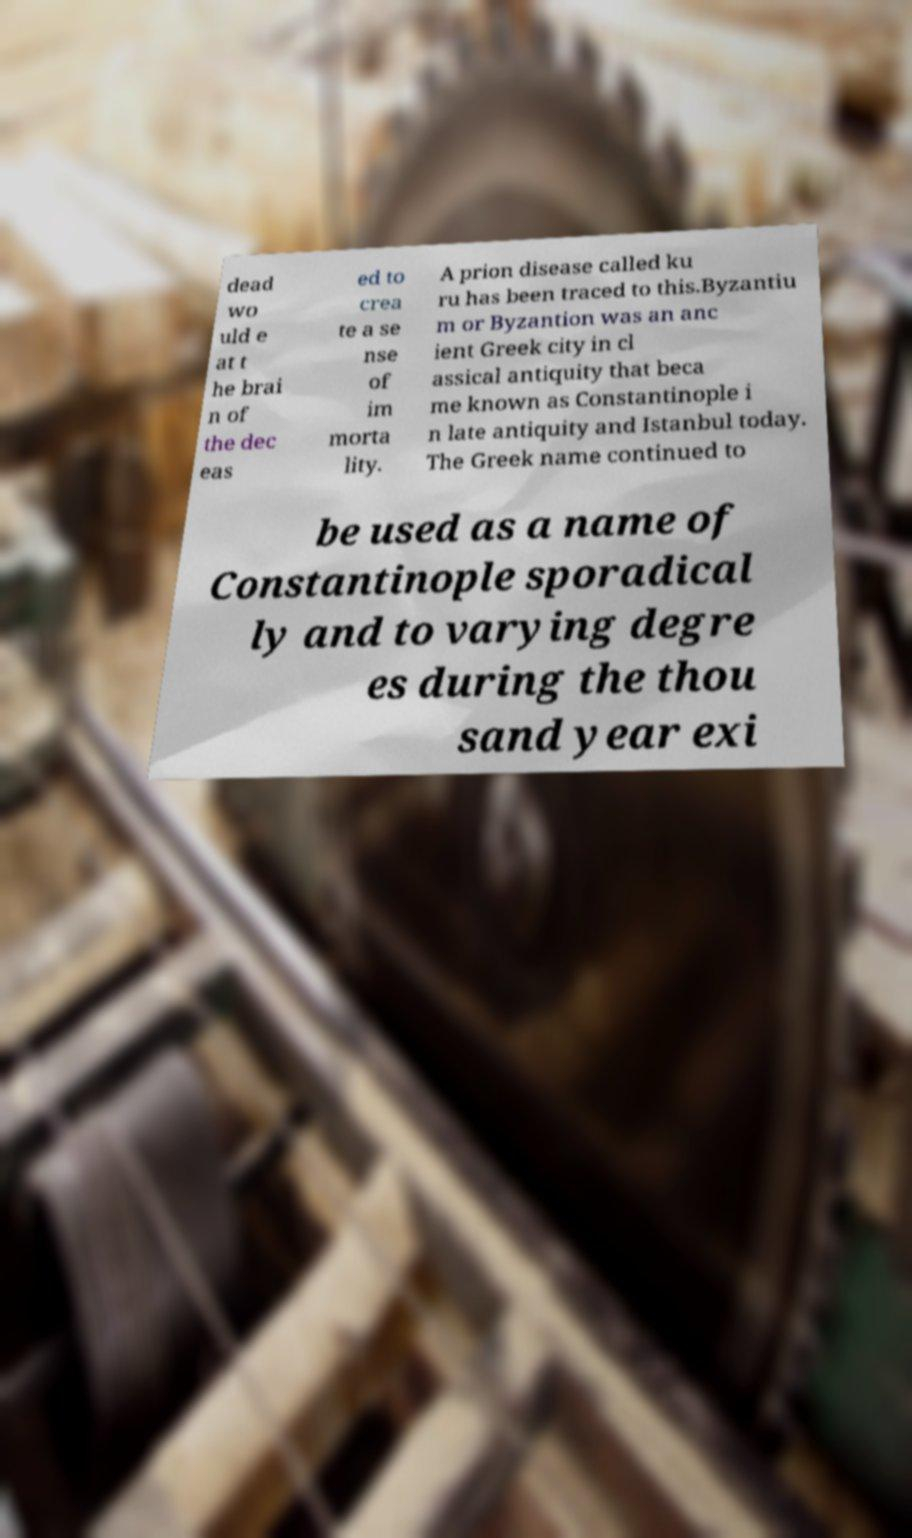I need the written content from this picture converted into text. Can you do that? dead wo uld e at t he brai n of the dec eas ed to crea te a se nse of im morta lity. A prion disease called ku ru has been traced to this.Byzantiu m or Byzantion was an anc ient Greek city in cl assical antiquity that beca me known as Constantinople i n late antiquity and Istanbul today. The Greek name continued to be used as a name of Constantinople sporadical ly and to varying degre es during the thou sand year exi 